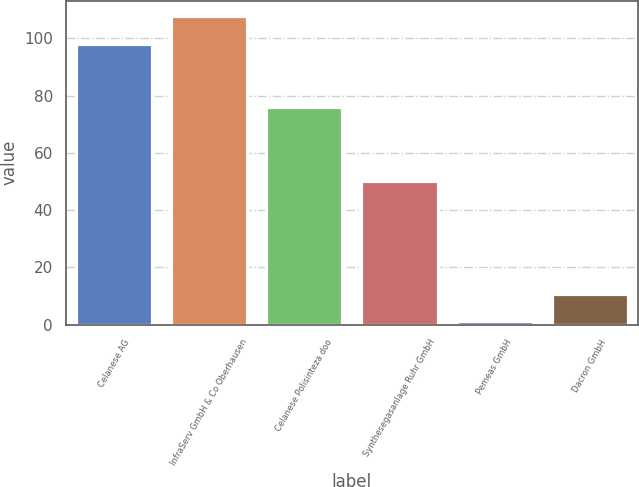Convert chart. <chart><loc_0><loc_0><loc_500><loc_500><bar_chart><fcel>Celanese AG<fcel>InfraServ GmbH & Co Oberhausen<fcel>Celanese Polisinteza doo<fcel>Synthesegasanlage Ruhr GmbH<fcel>Pemeas GmbH<fcel>Dacron GmbH<nl><fcel>98<fcel>107.68<fcel>76<fcel>50<fcel>1.19<fcel>10.87<nl></chart> 